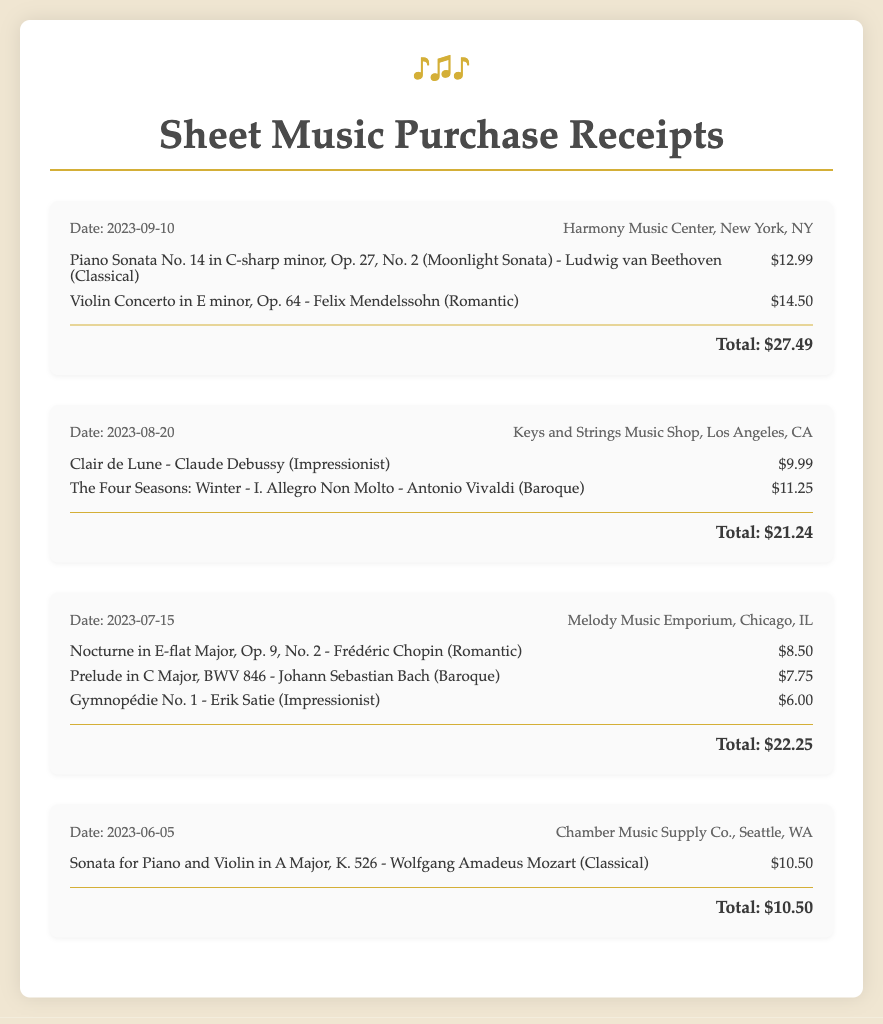What is the total amount spent on sheet music for the receipt dated September 10, 2023? The total amount for the receipt dated September 10, 2023 is listed at the bottom of the receipt, which is $27.49.
Answer: $27.49 How many items were purchased from the receipt dated August 20, 2023? From the receipt dated August 20, 2023, there are two items listed under the items section.
Answer: 2 Which music store did the purchase on June 5, 2023, take place? The name of the store is mentioned in the receipt header for the June 5, 2023 transaction.
Answer: Chamber Music Supply Co What is the price of "Gymnopédie No. 1"? The price of "Gymnopédie No. 1" is indicated next to the item in the receipt dated July 15, 2023.
Answer: $6.00 Who is the composer of "Clair de Lune"? The composer is specified next to the title on the receipt dated August 20, 2023.
Answer: Claude Debussy What genre is the "Nocturne in E-flat Major, Op. 9, No. 2"? The genre is categorized next to the title in the list of items on the receipt dated July 15, 2023.
Answer: Romantic Which receipt has the highest total amount? The totals of each receipt can be compared to determine which one is highest; upon checking the totals, the highest is from the receipt dated September 10, 2023.
Answer: $27.49 What is the date of the purchase for the "Violin Concerto in E minor, Op. 64"? The date is found in the receipt header where the item is listed on the receipt dated September 10, 2023.
Answer: 2023-09-10 